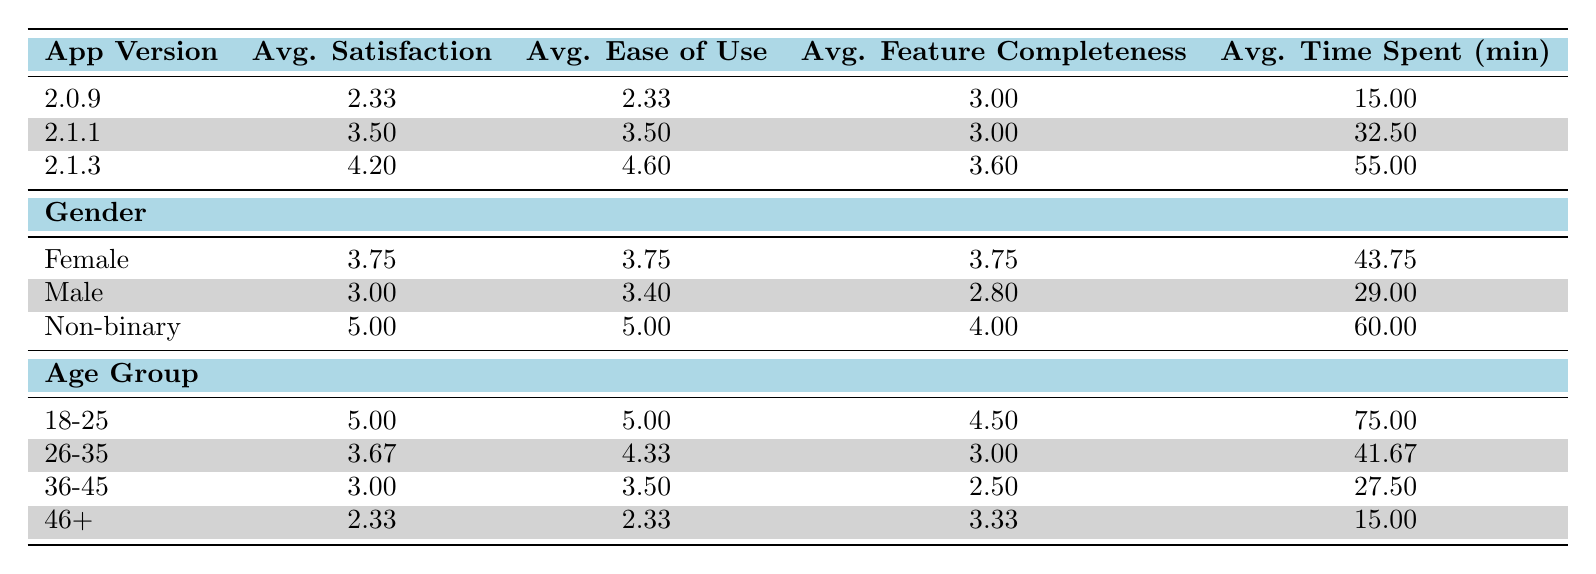What is the average satisfaction score for app version 2.1.3? The average satisfaction score for app version 2.1.3 is provided directly in the table, which shows it as 4.20.
Answer: 4.20 What is the average ease of use score for non-binary users? The table specifies that the average ease of use score for non-binary users is 5.00.
Answer: 5.00 How many app versions have an average satisfaction score higher than 3? The average satisfaction scores for app versions are as follows: 2.0.9 (2.33), 2.1.1 (3.50), and 2.1.3 (4.20). Among these, 2.1.1 and 2.1.3 have scores higher than 3. Thus, there are 2 versions.
Answer: 2 What is the average time spent by users in the age group of 36-45? The table shows that the average time spent by users aged 36-45 is 27.50 minutes.
Answer: 27.50 Is the average feature completeness score for male users less than that for female users? The average feature completeness for male users is 2.80, while for female users it is 3.75. Since 2.80 is less than 3.75, the statement is true.
Answer: Yes What is the average satisfaction score across all age groups? First, calculate the average satisfaction scores for each age group: 18-25 (5.00), 26-35 (3.67), 36-45 (3.00), and 46+ (2.33). Adding these gives 5.00 + 3.67 + 3.00 + 2.33 = 14.00, and dividing by the number of groups (4) gives 14.00 / 4 = 3.50.
Answer: 3.50 How does the average time spent by users under 25 compare to those over 45? The table indicates that average time spent by users aged 18-25 is 75.00 minutes and by users aged 46+ is 15.00 minutes. Therefore, 75.00 is greater than 15.00.
Answer: Under 25 spends more What is the difference in average satisfaction between male and female users? The average satisfaction score for female users is 3.75, and for male users, it is 3.00. The difference is calculated as 3.75 - 3.00 = 0.75.
Answer: 0.75 Are non-binary users the most satisfied demographic group? The average satisfaction score for non-binary users is 5.00, which is higher than the average scores for both male (3.00) and female (3.75) users. Hence, this statement is true.
Answer: Yes 